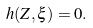Convert formula to latex. <formula><loc_0><loc_0><loc_500><loc_500>h ( Z , \xi ) = 0 .</formula> 